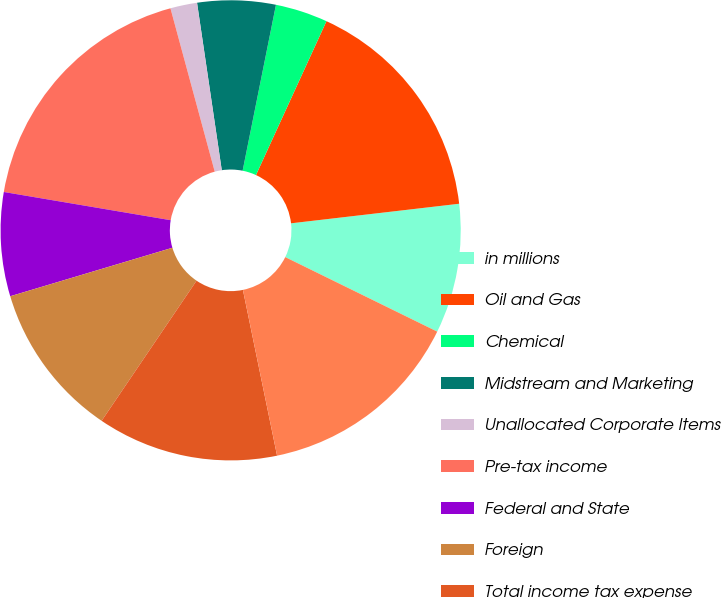Convert chart. <chart><loc_0><loc_0><loc_500><loc_500><pie_chart><fcel>in millions<fcel>Oil and Gas<fcel>Chemical<fcel>Midstream and Marketing<fcel>Unallocated Corporate Items<fcel>Pre-tax income<fcel>Federal and State<fcel>Foreign<fcel>Total income tax expense<fcel>Income from continuing<nl><fcel>9.1%<fcel>16.32%<fcel>3.68%<fcel>5.49%<fcel>1.88%<fcel>18.12%<fcel>7.29%<fcel>10.9%<fcel>12.71%<fcel>14.51%<nl></chart> 